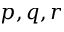<formula> <loc_0><loc_0><loc_500><loc_500>p , q , r</formula> 